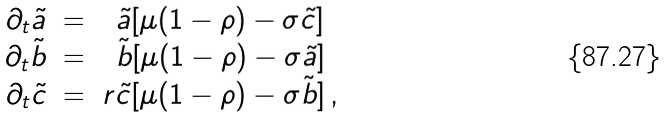<formula> <loc_0><loc_0><loc_500><loc_500>\begin{array} { c c c } \partial _ { t } \tilde { a } & = & \tilde { a } [ \mu ( 1 - \rho ) - \sigma \tilde { c } ] \\ \partial _ { t } \tilde { b } & = & \tilde { b } [ \mu ( 1 - \rho ) - \sigma \tilde { a } ] \\ \partial _ { t } \tilde { c } & = & r \tilde { c } [ \mu ( 1 - \rho ) - \sigma \tilde { b } ] \, , \end{array}</formula> 